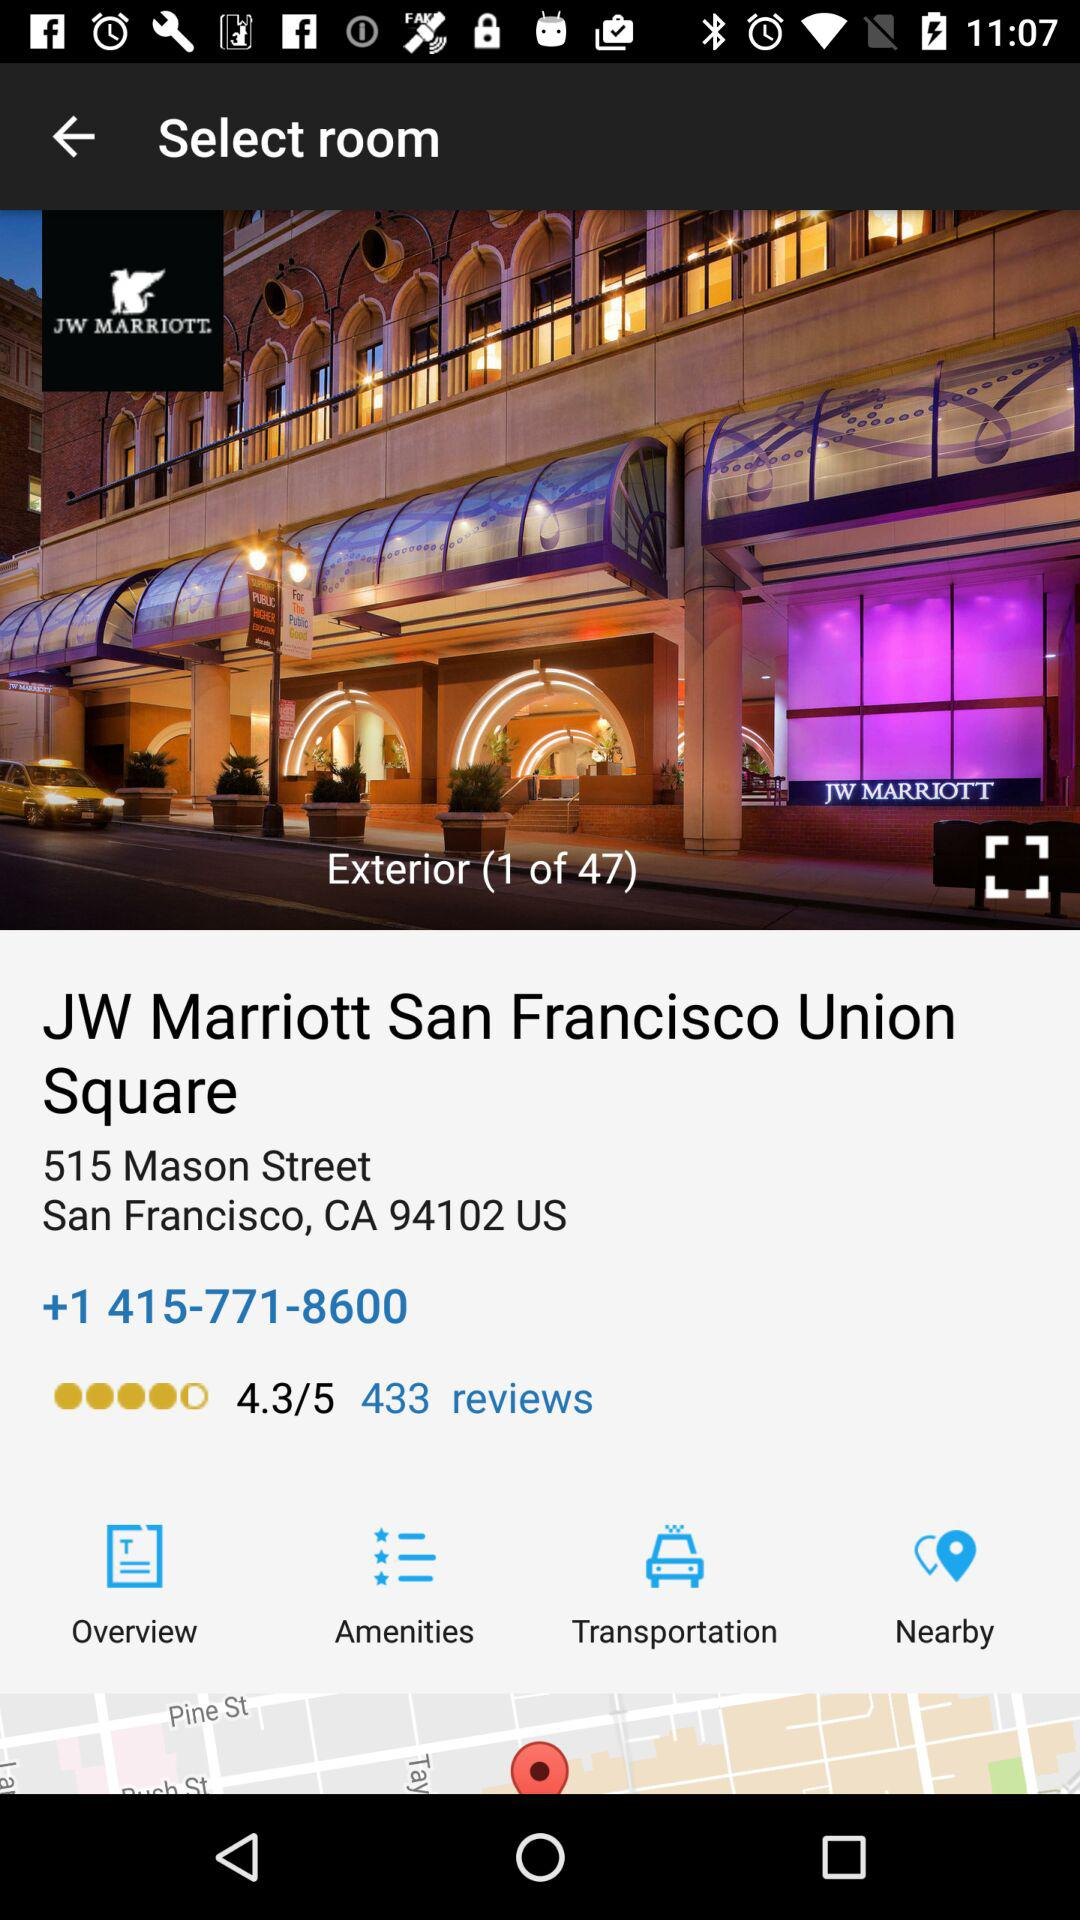How many pictures of JW Marriott are there? There are 47 photos. 